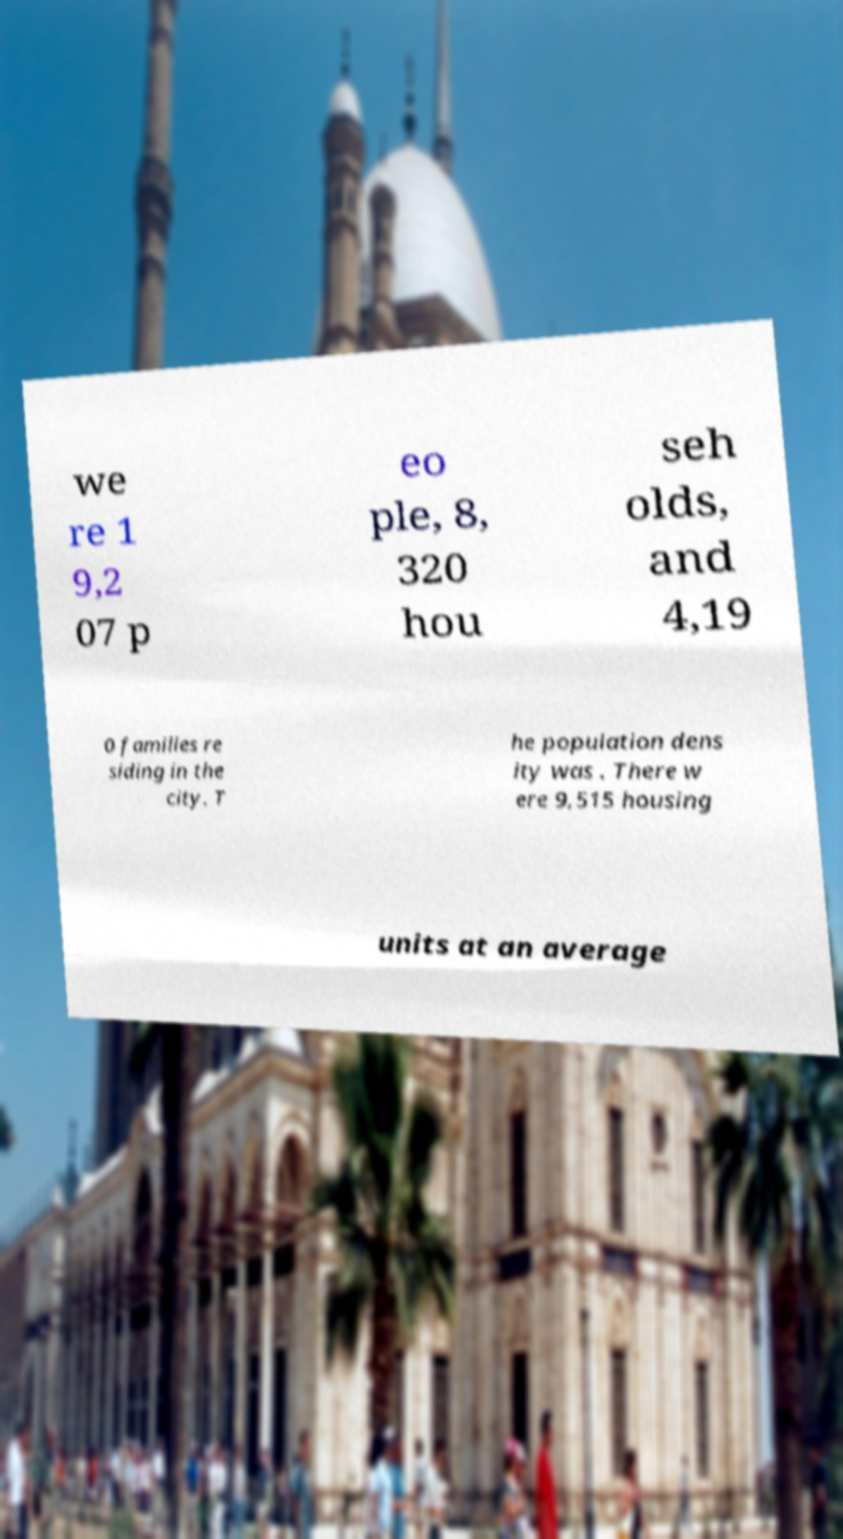Can you read and provide the text displayed in the image?This photo seems to have some interesting text. Can you extract and type it out for me? we re 1 9,2 07 p eo ple, 8, 320 hou seh olds, and 4,19 0 families re siding in the city. T he population dens ity was . There w ere 9,515 housing units at an average 